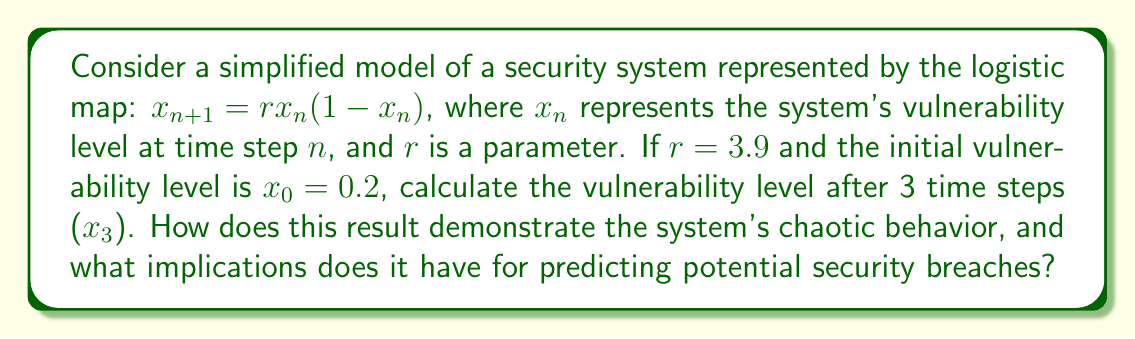What is the answer to this math problem? 1) We use the logistic map equation $x_{n+1} = rx_n(1-x_n)$ with $r=3.9$ and $x_0=0.2$.

2) Calculate $x_1$:
   $x_1 = 3.9 \cdot 0.2 \cdot (1-0.2) = 3.9 \cdot 0.2 \cdot 0.8 = 0.624$

3) Calculate $x_2$:
   $x_2 = 3.9 \cdot 0.624 \cdot (1-0.624) = 3.9 \cdot 0.624 \cdot 0.376 = 0.917376$

4) Calculate $x_3$:
   $x_3 = 3.9 \cdot 0.917376 \cdot (1-0.917376) = 3.9 \cdot 0.917376 \cdot 0.082624 = 0.295544$

5) The system demonstrates chaotic behavior because:
   a) Small changes in initial conditions lead to significantly different outcomes.
   b) The vulnerability level doesn't settle into a steady state or simple periodic pattern.
   c) Long-term prediction becomes increasingly difficult due to sensitivity to initial conditions.

6) Implications for security breach prediction:
   a) Precise long-term forecasting of vulnerability levels is challenging.
   b) Regular reassessment of the security system is necessary.
   c) Multiple scenarios and initial conditions should be considered in security planning.
   d) Adaptive and responsive security measures are crucial to address the unpredictable nature of the system.
Answer: $x_3 \approx 0.295544$; chaotic behavior implies unpredictable long-term vulnerability, necessitating adaptive security measures. 